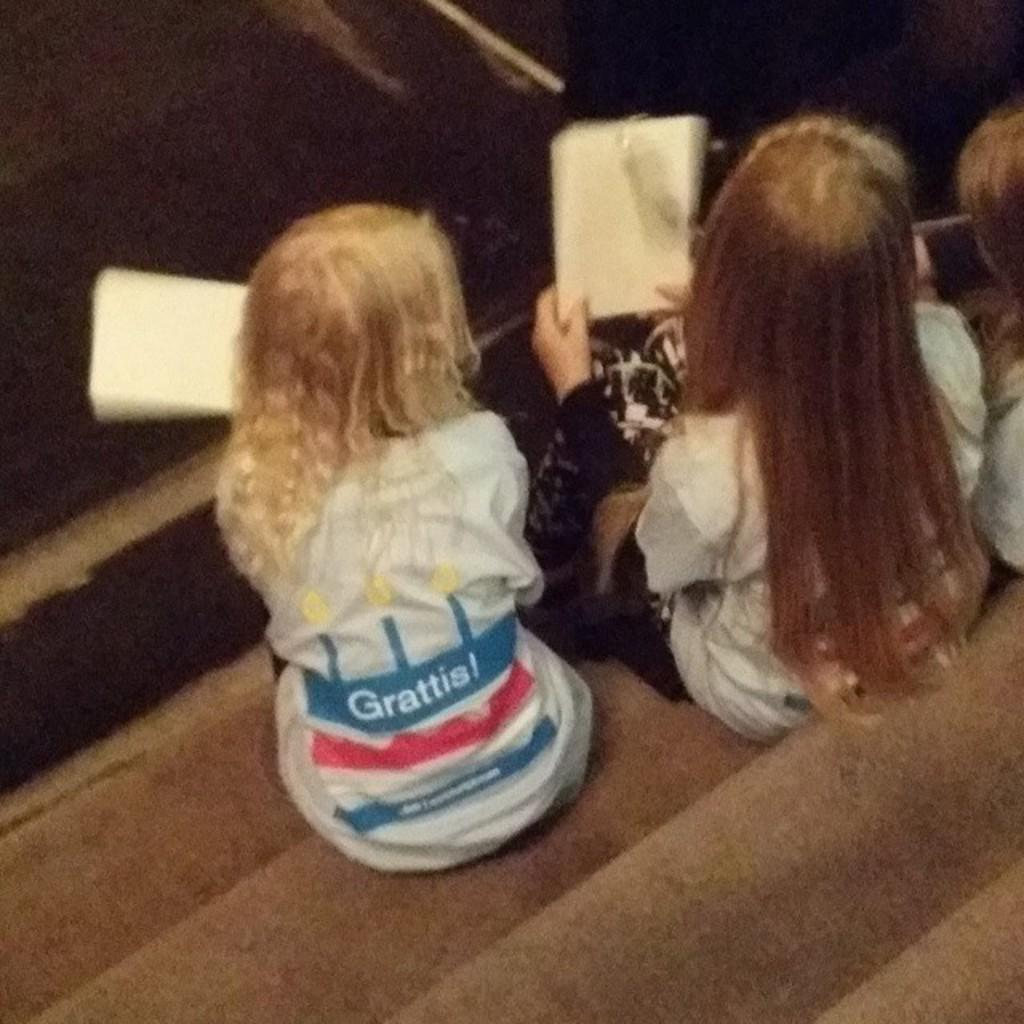How many girls are in the image? There are three girls in the image. Where are the girls sitting? The girls are sitting on a staircase. What are two of the girls holding in their hands? Two of the girls are holding books in their hands. What type of engine can be seen powering the quince in the image? There is no engine or quince present in the image; it features three girls sitting on a staircase. 